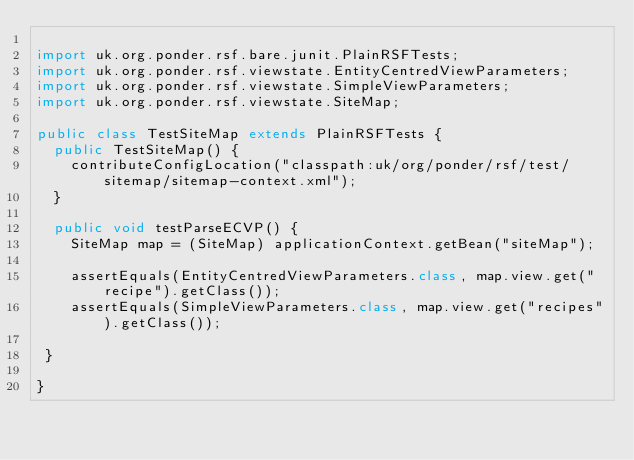<code> <loc_0><loc_0><loc_500><loc_500><_Java_>
import uk.org.ponder.rsf.bare.junit.PlainRSFTests;
import uk.org.ponder.rsf.viewstate.EntityCentredViewParameters;
import uk.org.ponder.rsf.viewstate.SimpleViewParameters;
import uk.org.ponder.rsf.viewstate.SiteMap;

public class TestSiteMap extends PlainRSFTests {
  public TestSiteMap() {
    contributeConfigLocation("classpath:uk/org/ponder/rsf/test/sitemap/sitemap-context.xml");
  }
   
  public void testParseECVP() {
    SiteMap map = (SiteMap) applicationContext.getBean("siteMap");
    
    assertEquals(EntityCentredViewParameters.class, map.view.get("recipe").getClass());
    assertEquals(SimpleViewParameters.class, map.view.get("recipes").getClass());
    
 }

}

</code> 